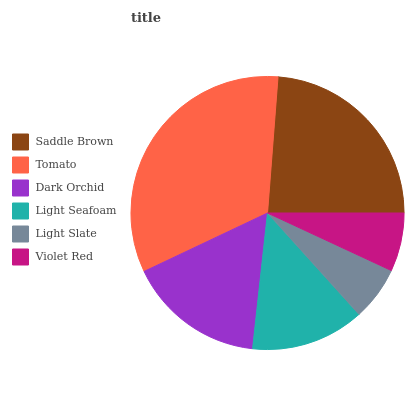Is Light Slate the minimum?
Answer yes or no. Yes. Is Tomato the maximum?
Answer yes or no. Yes. Is Dark Orchid the minimum?
Answer yes or no. No. Is Dark Orchid the maximum?
Answer yes or no. No. Is Tomato greater than Dark Orchid?
Answer yes or no. Yes. Is Dark Orchid less than Tomato?
Answer yes or no. Yes. Is Dark Orchid greater than Tomato?
Answer yes or no. No. Is Tomato less than Dark Orchid?
Answer yes or no. No. Is Dark Orchid the high median?
Answer yes or no. Yes. Is Light Seafoam the low median?
Answer yes or no. Yes. Is Saddle Brown the high median?
Answer yes or no. No. Is Light Slate the low median?
Answer yes or no. No. 